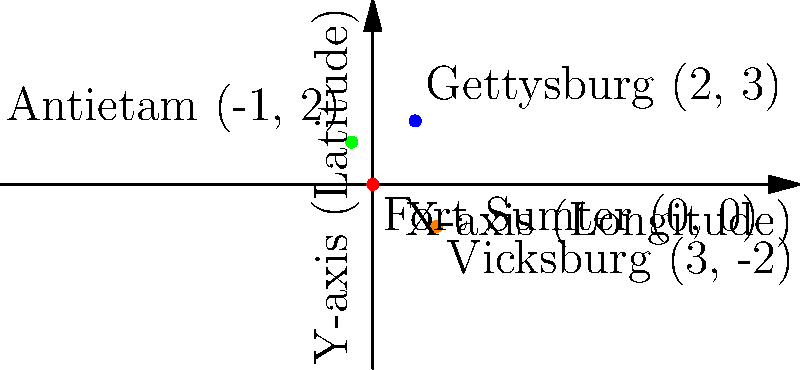On the given coordinate plane, four key battle locations of the Civil War are plotted. If the origin (0,0) represents Fort Sumter, what are the coordinates of the Battle of Gettysburg? To determine the coordinates of the Battle of Gettysburg, we need to:

1. Identify the point labeled "Gettysburg" on the coordinate plane.
2. Read the x-coordinate (longitude) of this point.
3. Read the y-coordinate (latitude) of this point.

Looking at the graph:
1. Gettysburg is represented by the blue dot.
2. The x-coordinate (longitude) of Gettysburg is 2 units to the right of the origin.
3. The y-coordinate (latitude) of Gettysburg is 3 units above the origin.

Therefore, the coordinates of the Battle of Gettysburg are (2, 3).
Answer: $(2, 3)$ 